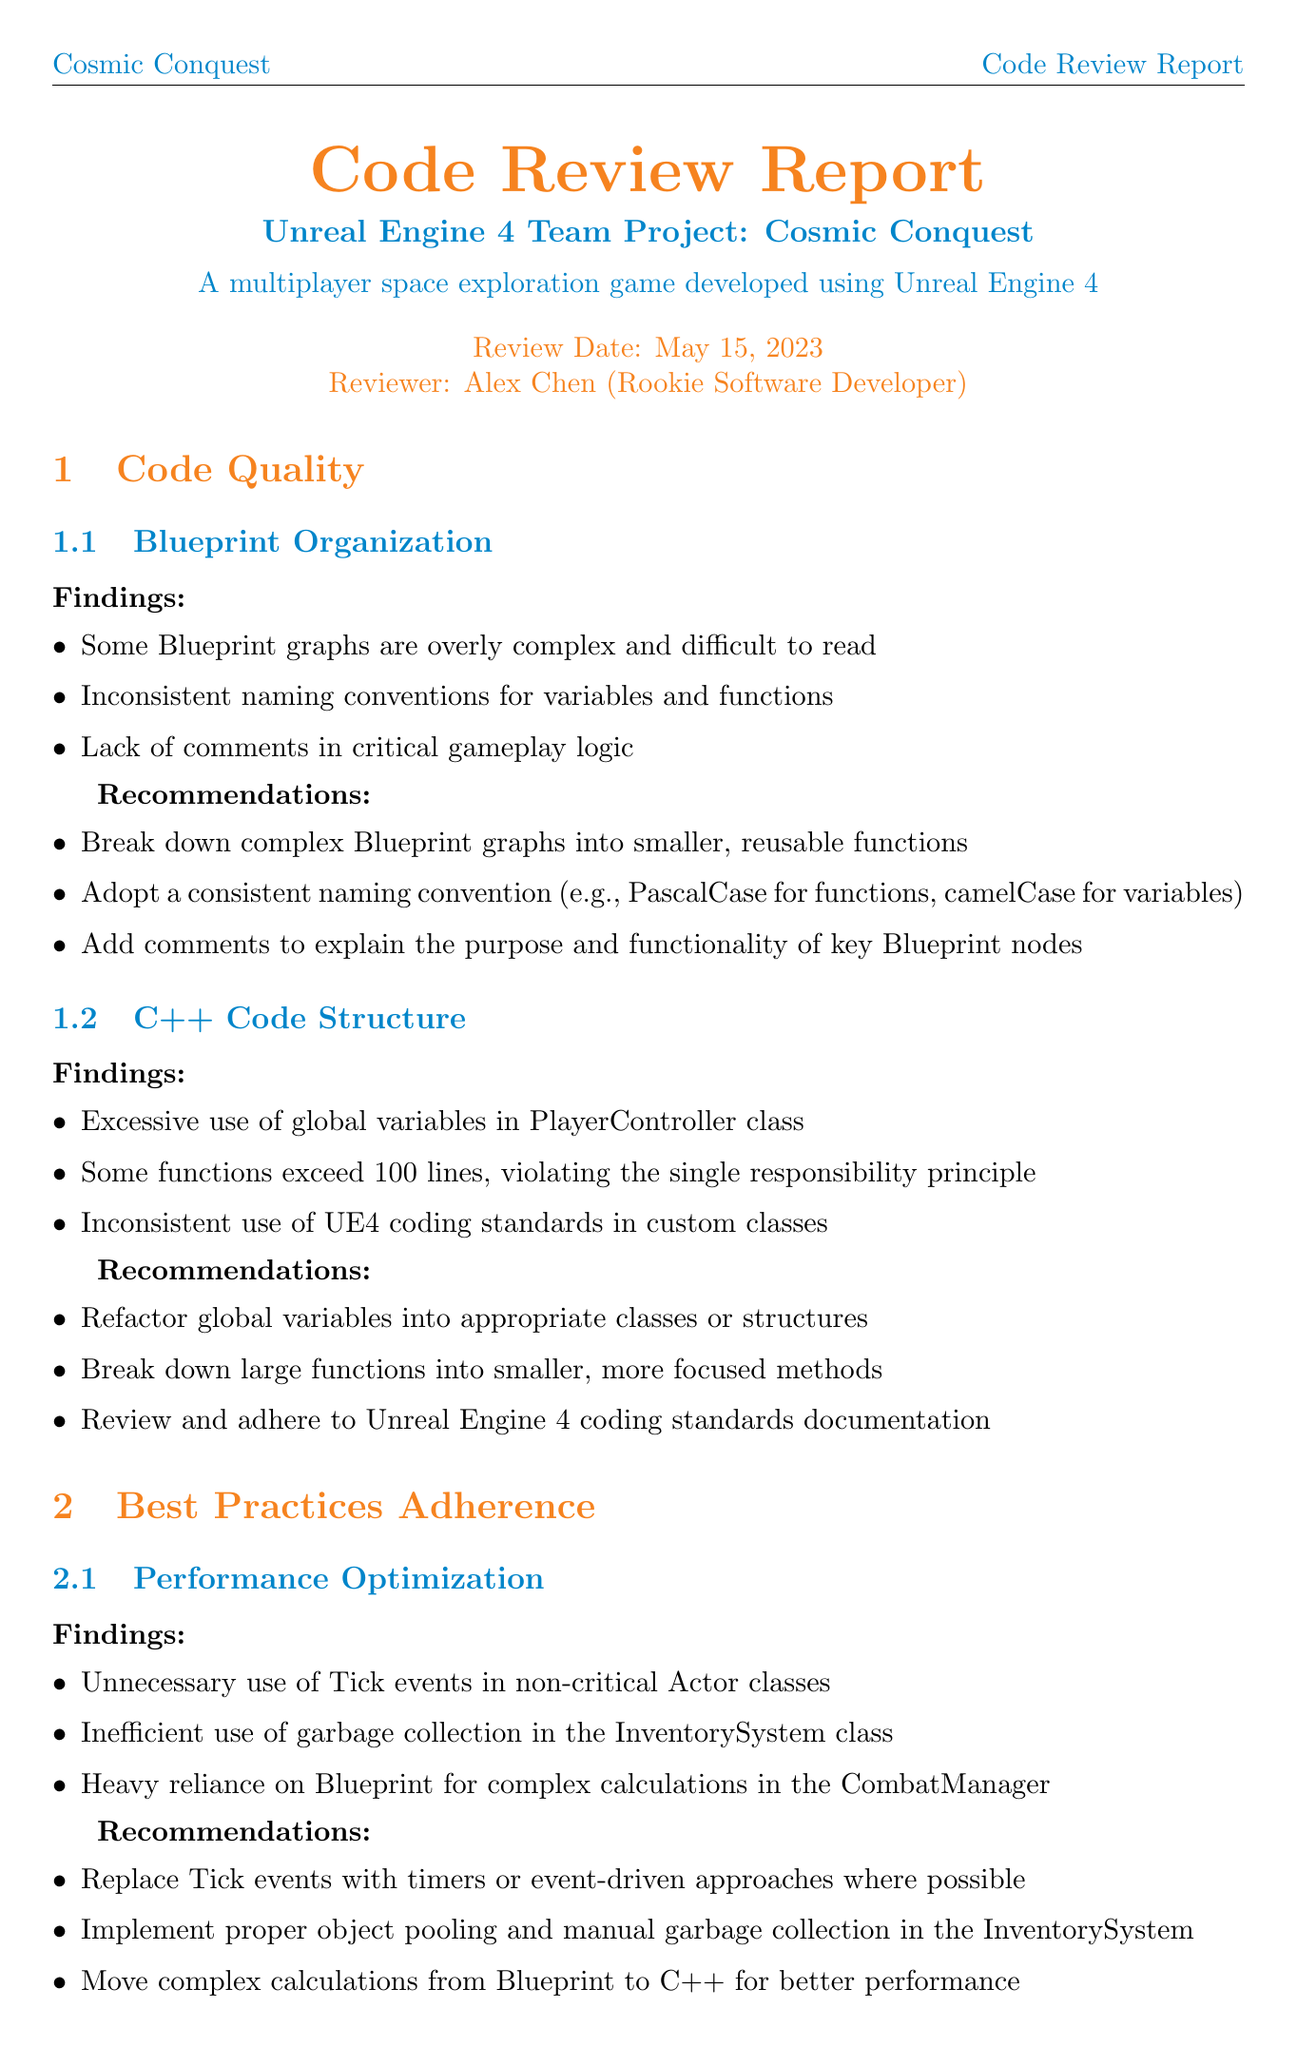What is the project name? The project name is mentioned in the title and context of the document as "Cosmic Conquest".
Answer: Cosmic Conquest Who is the reviewer? The reviewer's name is provided in the header section of the document as "Alex Chen".
Answer: Alex Chen When was the code review conducted? The review date is specified in the document as "May 15, 2023".
Answer: May 15, 2023 What is one finding related to Blueprint Organization? The document lists findings under Blueprint Organization that highlight the issues in the code, one of which is "Some Blueprint graphs are overly complex and difficult to read".
Answer: Some Blueprint graphs are overly complex and difficult to read What are the priority actions listed in the conclusion? The conclusion section outlines the priority actions for improvements, which are collectively summarized, including "Refactor complex Blueprint graphs and C++ functions".
Answer: Refactor complex Blueprint graphs and C++ functions Which coding standard is mentioned regarding C++ code structure? The document advises on consistent usage of coding standards extracted from Unreal Engine 4 coding guidelines under C++ Code Structure section.
Answer: Unreal Engine 4 coding standards What is one recommendation for performance optimization? The recommendations following findings in performance optimization suggest "Replace Tick events with timers or event-driven approaches where possible".
Answer: Replace Tick events with timers or event-driven approaches where possible Is there a section discussing testing and quality assurance? There is a dedicated section titled "Testing and Quality Assurance" addressing findings and recommendations, indicating it is indeed present in the document.
Answer: Yes What is highlighted as lacking in documentation findings? The document identifies "Lack of in-code documentation for custom classes and functions" as a significant issue under the Documentation findings.
Answer: Lack of in-code documentation for custom classes and functions 